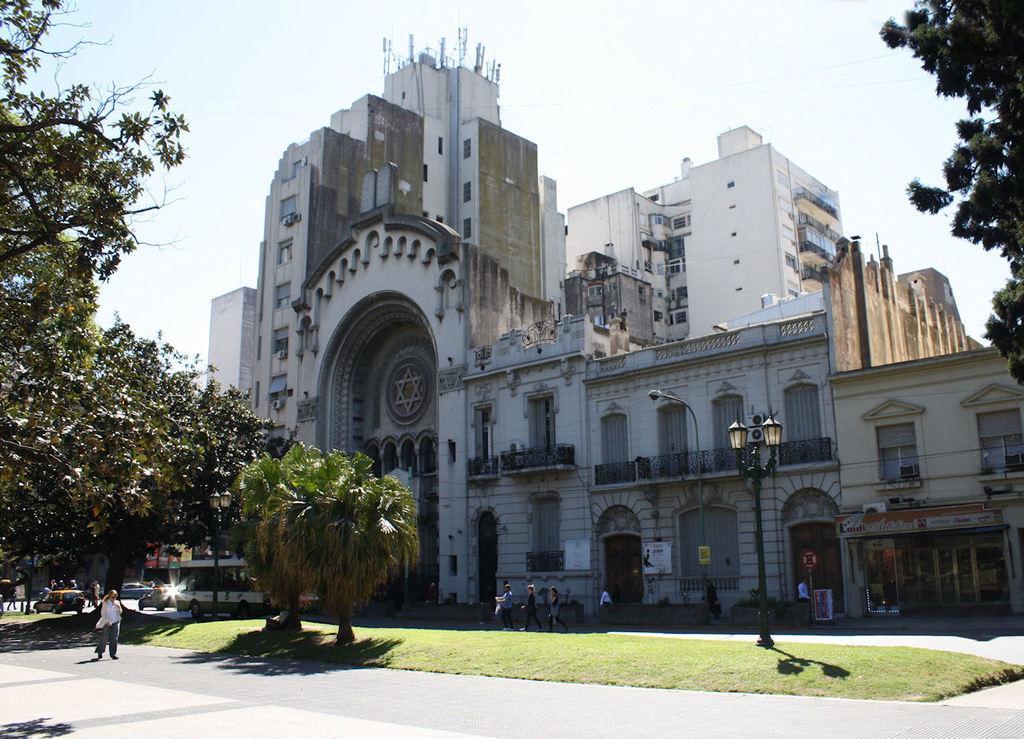Describe this image in one or two sentences. In this image, we can see buildings, trees, poles, lights, boards and some vehicles and people on the road. 